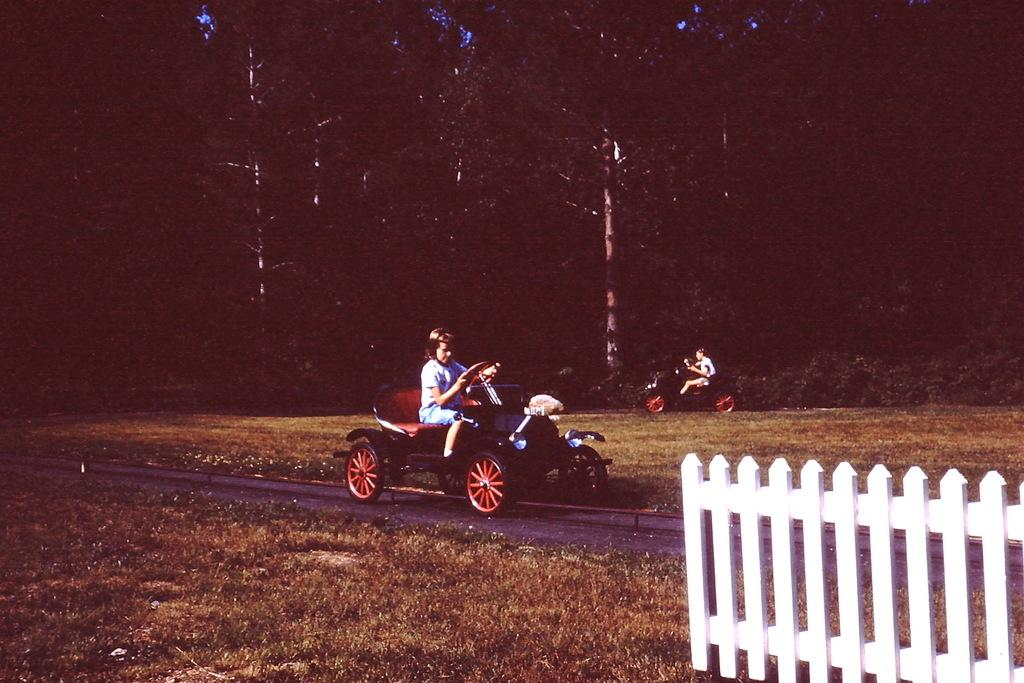What are the people in the image doing? The people in the image are driving a car. Where is the car located in the image? The car is on the road. What type of vegetation can be seen in the image? There are trees and grass in the image. What kind of barrier is present in the image? There is a fence in the image. What type of oatmeal is being cooked in the image? There is no oatmeal or cooking activity present in the image. Who is recording the people driving the car in the image? There is no indication of anyone recording the people driving the car in the image. 